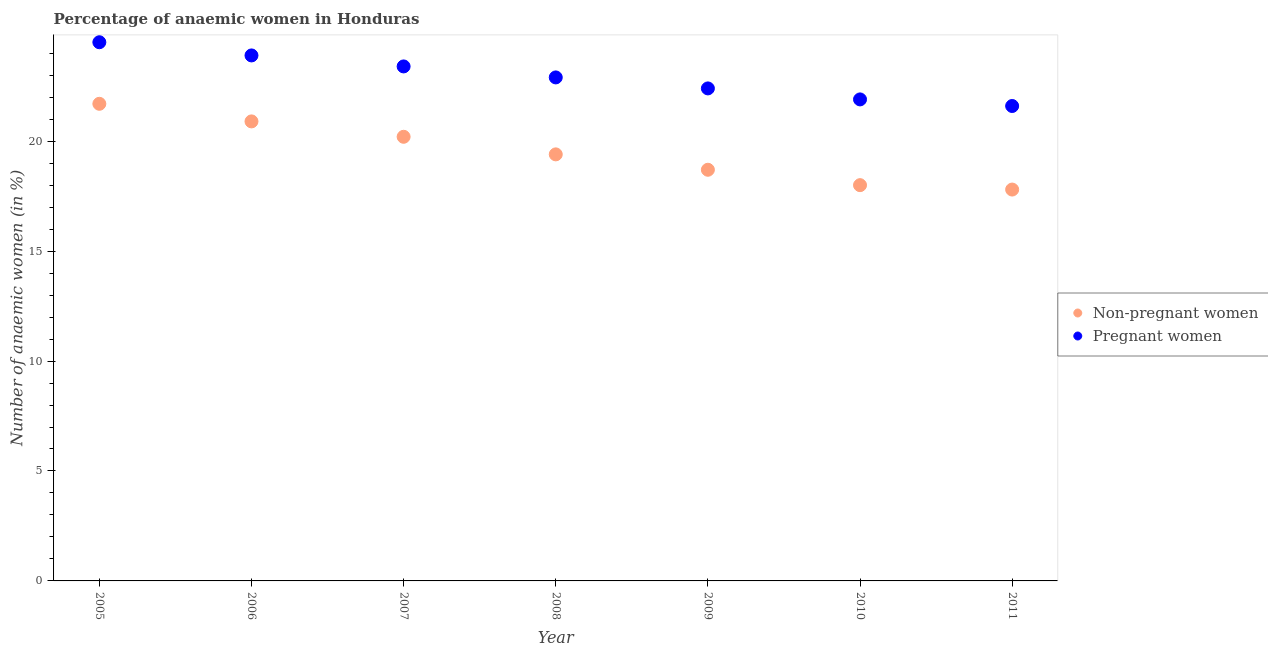How many different coloured dotlines are there?
Give a very brief answer. 2. Is the number of dotlines equal to the number of legend labels?
Your response must be concise. Yes. What is the percentage of pregnant anaemic women in 2011?
Offer a terse response. 21.6. Across all years, what is the maximum percentage of pregnant anaemic women?
Offer a very short reply. 24.5. Across all years, what is the minimum percentage of non-pregnant anaemic women?
Provide a succinct answer. 17.8. In which year was the percentage of non-pregnant anaemic women maximum?
Offer a terse response. 2005. What is the total percentage of pregnant anaemic women in the graph?
Your response must be concise. 160.6. What is the difference between the percentage of pregnant anaemic women in 2008 and that in 2010?
Provide a succinct answer. 1. What is the difference between the percentage of pregnant anaemic women in 2011 and the percentage of non-pregnant anaemic women in 2008?
Provide a succinct answer. 2.2. What is the average percentage of non-pregnant anaemic women per year?
Your response must be concise. 19.53. In the year 2007, what is the difference between the percentage of pregnant anaemic women and percentage of non-pregnant anaemic women?
Your response must be concise. 3.2. What is the ratio of the percentage of pregnant anaemic women in 2005 to that in 2006?
Offer a very short reply. 1.03. Is the percentage of non-pregnant anaemic women in 2006 less than that in 2008?
Make the answer very short. No. Is the difference between the percentage of non-pregnant anaemic women in 2005 and 2008 greater than the difference between the percentage of pregnant anaemic women in 2005 and 2008?
Offer a very short reply. Yes. What is the difference between the highest and the second highest percentage of pregnant anaemic women?
Your answer should be compact. 0.6. What is the difference between the highest and the lowest percentage of pregnant anaemic women?
Offer a terse response. 2.9. In how many years, is the percentage of non-pregnant anaemic women greater than the average percentage of non-pregnant anaemic women taken over all years?
Ensure brevity in your answer.  3. Is the sum of the percentage of non-pregnant anaemic women in 2008 and 2011 greater than the maximum percentage of pregnant anaemic women across all years?
Your answer should be compact. Yes. Does the percentage of non-pregnant anaemic women monotonically increase over the years?
Your answer should be very brief. No. Is the percentage of non-pregnant anaemic women strictly less than the percentage of pregnant anaemic women over the years?
Offer a terse response. Yes. How many dotlines are there?
Offer a very short reply. 2. How many years are there in the graph?
Offer a terse response. 7. What is the difference between two consecutive major ticks on the Y-axis?
Your answer should be compact. 5. Are the values on the major ticks of Y-axis written in scientific E-notation?
Offer a terse response. No. Does the graph contain any zero values?
Your response must be concise. No. Does the graph contain grids?
Offer a very short reply. No. How are the legend labels stacked?
Give a very brief answer. Vertical. What is the title of the graph?
Ensure brevity in your answer.  Percentage of anaemic women in Honduras. What is the label or title of the Y-axis?
Provide a succinct answer. Number of anaemic women (in %). What is the Number of anaemic women (in %) of Non-pregnant women in 2005?
Your response must be concise. 21.7. What is the Number of anaemic women (in %) of Non-pregnant women in 2006?
Make the answer very short. 20.9. What is the Number of anaemic women (in %) of Pregnant women in 2006?
Your response must be concise. 23.9. What is the Number of anaemic women (in %) in Non-pregnant women in 2007?
Your answer should be compact. 20.2. What is the Number of anaemic women (in %) of Pregnant women in 2007?
Ensure brevity in your answer.  23.4. What is the Number of anaemic women (in %) in Pregnant women in 2008?
Your answer should be very brief. 22.9. What is the Number of anaemic women (in %) of Pregnant women in 2009?
Provide a succinct answer. 22.4. What is the Number of anaemic women (in %) in Non-pregnant women in 2010?
Your response must be concise. 18. What is the Number of anaemic women (in %) of Pregnant women in 2010?
Offer a very short reply. 21.9. What is the Number of anaemic women (in %) of Non-pregnant women in 2011?
Offer a terse response. 17.8. What is the Number of anaemic women (in %) in Pregnant women in 2011?
Offer a terse response. 21.6. Across all years, what is the maximum Number of anaemic women (in %) of Non-pregnant women?
Provide a succinct answer. 21.7. Across all years, what is the minimum Number of anaemic women (in %) in Pregnant women?
Offer a terse response. 21.6. What is the total Number of anaemic women (in %) of Non-pregnant women in the graph?
Offer a terse response. 136.7. What is the total Number of anaemic women (in %) of Pregnant women in the graph?
Your answer should be very brief. 160.6. What is the difference between the Number of anaemic women (in %) in Non-pregnant women in 2005 and that in 2006?
Provide a short and direct response. 0.8. What is the difference between the Number of anaemic women (in %) in Pregnant women in 2005 and that in 2007?
Your answer should be very brief. 1.1. What is the difference between the Number of anaemic women (in %) of Non-pregnant women in 2005 and that in 2009?
Ensure brevity in your answer.  3. What is the difference between the Number of anaemic women (in %) of Pregnant women in 2006 and that in 2008?
Keep it short and to the point. 1. What is the difference between the Number of anaemic women (in %) of Non-pregnant women in 2006 and that in 2009?
Make the answer very short. 2.2. What is the difference between the Number of anaemic women (in %) of Non-pregnant women in 2006 and that in 2010?
Your answer should be compact. 2.9. What is the difference between the Number of anaemic women (in %) of Pregnant women in 2006 and that in 2010?
Your answer should be very brief. 2. What is the difference between the Number of anaemic women (in %) in Non-pregnant women in 2006 and that in 2011?
Keep it short and to the point. 3.1. What is the difference between the Number of anaemic women (in %) of Pregnant women in 2007 and that in 2009?
Make the answer very short. 1. What is the difference between the Number of anaemic women (in %) in Non-pregnant women in 2007 and that in 2011?
Provide a succinct answer. 2.4. What is the difference between the Number of anaemic women (in %) of Non-pregnant women in 2008 and that in 2009?
Keep it short and to the point. 0.7. What is the difference between the Number of anaemic women (in %) of Pregnant women in 2008 and that in 2010?
Your answer should be very brief. 1. What is the difference between the Number of anaemic women (in %) of Non-pregnant women in 2008 and that in 2011?
Provide a short and direct response. 1.6. What is the difference between the Number of anaemic women (in %) in Pregnant women in 2008 and that in 2011?
Offer a terse response. 1.3. What is the difference between the Number of anaemic women (in %) in Non-pregnant women in 2009 and that in 2010?
Make the answer very short. 0.7. What is the difference between the Number of anaemic women (in %) in Pregnant women in 2009 and that in 2010?
Offer a very short reply. 0.5. What is the difference between the Number of anaemic women (in %) in Pregnant women in 2010 and that in 2011?
Your answer should be compact. 0.3. What is the difference between the Number of anaemic women (in %) of Non-pregnant women in 2005 and the Number of anaemic women (in %) of Pregnant women in 2006?
Offer a very short reply. -2.2. What is the difference between the Number of anaemic women (in %) in Non-pregnant women in 2005 and the Number of anaemic women (in %) in Pregnant women in 2010?
Your response must be concise. -0.2. What is the difference between the Number of anaemic women (in %) of Non-pregnant women in 2005 and the Number of anaemic women (in %) of Pregnant women in 2011?
Provide a succinct answer. 0.1. What is the difference between the Number of anaemic women (in %) in Non-pregnant women in 2006 and the Number of anaemic women (in %) in Pregnant women in 2007?
Your answer should be very brief. -2.5. What is the difference between the Number of anaemic women (in %) in Non-pregnant women in 2006 and the Number of anaemic women (in %) in Pregnant women in 2008?
Keep it short and to the point. -2. What is the difference between the Number of anaemic women (in %) of Non-pregnant women in 2006 and the Number of anaemic women (in %) of Pregnant women in 2010?
Your answer should be very brief. -1. What is the difference between the Number of anaemic women (in %) of Non-pregnant women in 2006 and the Number of anaemic women (in %) of Pregnant women in 2011?
Offer a very short reply. -0.7. What is the difference between the Number of anaemic women (in %) in Non-pregnant women in 2007 and the Number of anaemic women (in %) in Pregnant women in 2009?
Provide a succinct answer. -2.2. What is the difference between the Number of anaemic women (in %) in Non-pregnant women in 2007 and the Number of anaemic women (in %) in Pregnant women in 2010?
Your answer should be very brief. -1.7. What is the difference between the Number of anaemic women (in %) of Non-pregnant women in 2007 and the Number of anaemic women (in %) of Pregnant women in 2011?
Keep it short and to the point. -1.4. What is the difference between the Number of anaemic women (in %) in Non-pregnant women in 2008 and the Number of anaemic women (in %) in Pregnant women in 2011?
Ensure brevity in your answer.  -2.2. What is the difference between the Number of anaemic women (in %) of Non-pregnant women in 2009 and the Number of anaemic women (in %) of Pregnant women in 2010?
Make the answer very short. -3.2. What is the average Number of anaemic women (in %) of Non-pregnant women per year?
Provide a succinct answer. 19.53. What is the average Number of anaemic women (in %) of Pregnant women per year?
Your answer should be compact. 22.94. In the year 2008, what is the difference between the Number of anaemic women (in %) of Non-pregnant women and Number of anaemic women (in %) of Pregnant women?
Keep it short and to the point. -3.5. In the year 2009, what is the difference between the Number of anaemic women (in %) of Non-pregnant women and Number of anaemic women (in %) of Pregnant women?
Your answer should be very brief. -3.7. In the year 2010, what is the difference between the Number of anaemic women (in %) in Non-pregnant women and Number of anaemic women (in %) in Pregnant women?
Offer a very short reply. -3.9. In the year 2011, what is the difference between the Number of anaemic women (in %) of Non-pregnant women and Number of anaemic women (in %) of Pregnant women?
Your answer should be compact. -3.8. What is the ratio of the Number of anaemic women (in %) in Non-pregnant women in 2005 to that in 2006?
Ensure brevity in your answer.  1.04. What is the ratio of the Number of anaemic women (in %) of Pregnant women in 2005 to that in 2006?
Provide a succinct answer. 1.03. What is the ratio of the Number of anaemic women (in %) in Non-pregnant women in 2005 to that in 2007?
Offer a terse response. 1.07. What is the ratio of the Number of anaemic women (in %) in Pregnant women in 2005 to that in 2007?
Keep it short and to the point. 1.05. What is the ratio of the Number of anaemic women (in %) of Non-pregnant women in 2005 to that in 2008?
Ensure brevity in your answer.  1.12. What is the ratio of the Number of anaemic women (in %) in Pregnant women in 2005 to that in 2008?
Keep it short and to the point. 1.07. What is the ratio of the Number of anaemic women (in %) in Non-pregnant women in 2005 to that in 2009?
Your answer should be compact. 1.16. What is the ratio of the Number of anaemic women (in %) of Pregnant women in 2005 to that in 2009?
Your response must be concise. 1.09. What is the ratio of the Number of anaemic women (in %) in Non-pregnant women in 2005 to that in 2010?
Ensure brevity in your answer.  1.21. What is the ratio of the Number of anaemic women (in %) of Pregnant women in 2005 to that in 2010?
Ensure brevity in your answer.  1.12. What is the ratio of the Number of anaemic women (in %) of Non-pregnant women in 2005 to that in 2011?
Give a very brief answer. 1.22. What is the ratio of the Number of anaemic women (in %) of Pregnant women in 2005 to that in 2011?
Your answer should be very brief. 1.13. What is the ratio of the Number of anaemic women (in %) in Non-pregnant women in 2006 to that in 2007?
Provide a succinct answer. 1.03. What is the ratio of the Number of anaemic women (in %) of Pregnant women in 2006 to that in 2007?
Make the answer very short. 1.02. What is the ratio of the Number of anaemic women (in %) in Non-pregnant women in 2006 to that in 2008?
Give a very brief answer. 1.08. What is the ratio of the Number of anaemic women (in %) in Pregnant women in 2006 to that in 2008?
Keep it short and to the point. 1.04. What is the ratio of the Number of anaemic women (in %) in Non-pregnant women in 2006 to that in 2009?
Your answer should be very brief. 1.12. What is the ratio of the Number of anaemic women (in %) in Pregnant women in 2006 to that in 2009?
Provide a succinct answer. 1.07. What is the ratio of the Number of anaemic women (in %) of Non-pregnant women in 2006 to that in 2010?
Your answer should be very brief. 1.16. What is the ratio of the Number of anaemic women (in %) of Pregnant women in 2006 to that in 2010?
Provide a short and direct response. 1.09. What is the ratio of the Number of anaemic women (in %) of Non-pregnant women in 2006 to that in 2011?
Provide a short and direct response. 1.17. What is the ratio of the Number of anaemic women (in %) in Pregnant women in 2006 to that in 2011?
Provide a succinct answer. 1.11. What is the ratio of the Number of anaemic women (in %) in Non-pregnant women in 2007 to that in 2008?
Offer a terse response. 1.04. What is the ratio of the Number of anaemic women (in %) in Pregnant women in 2007 to that in 2008?
Your response must be concise. 1.02. What is the ratio of the Number of anaemic women (in %) in Non-pregnant women in 2007 to that in 2009?
Your answer should be compact. 1.08. What is the ratio of the Number of anaemic women (in %) of Pregnant women in 2007 to that in 2009?
Make the answer very short. 1.04. What is the ratio of the Number of anaemic women (in %) in Non-pregnant women in 2007 to that in 2010?
Your response must be concise. 1.12. What is the ratio of the Number of anaemic women (in %) in Pregnant women in 2007 to that in 2010?
Your answer should be very brief. 1.07. What is the ratio of the Number of anaemic women (in %) in Non-pregnant women in 2007 to that in 2011?
Give a very brief answer. 1.13. What is the ratio of the Number of anaemic women (in %) of Non-pregnant women in 2008 to that in 2009?
Offer a terse response. 1.04. What is the ratio of the Number of anaemic women (in %) in Pregnant women in 2008 to that in 2009?
Offer a terse response. 1.02. What is the ratio of the Number of anaemic women (in %) of Non-pregnant women in 2008 to that in 2010?
Provide a succinct answer. 1.08. What is the ratio of the Number of anaemic women (in %) of Pregnant women in 2008 to that in 2010?
Offer a terse response. 1.05. What is the ratio of the Number of anaemic women (in %) in Non-pregnant women in 2008 to that in 2011?
Offer a terse response. 1.09. What is the ratio of the Number of anaemic women (in %) of Pregnant women in 2008 to that in 2011?
Provide a short and direct response. 1.06. What is the ratio of the Number of anaemic women (in %) in Non-pregnant women in 2009 to that in 2010?
Ensure brevity in your answer.  1.04. What is the ratio of the Number of anaemic women (in %) of Pregnant women in 2009 to that in 2010?
Ensure brevity in your answer.  1.02. What is the ratio of the Number of anaemic women (in %) in Non-pregnant women in 2009 to that in 2011?
Ensure brevity in your answer.  1.05. What is the ratio of the Number of anaemic women (in %) of Non-pregnant women in 2010 to that in 2011?
Ensure brevity in your answer.  1.01. What is the ratio of the Number of anaemic women (in %) of Pregnant women in 2010 to that in 2011?
Keep it short and to the point. 1.01. What is the difference between the highest and the lowest Number of anaemic women (in %) of Pregnant women?
Offer a very short reply. 2.9. 